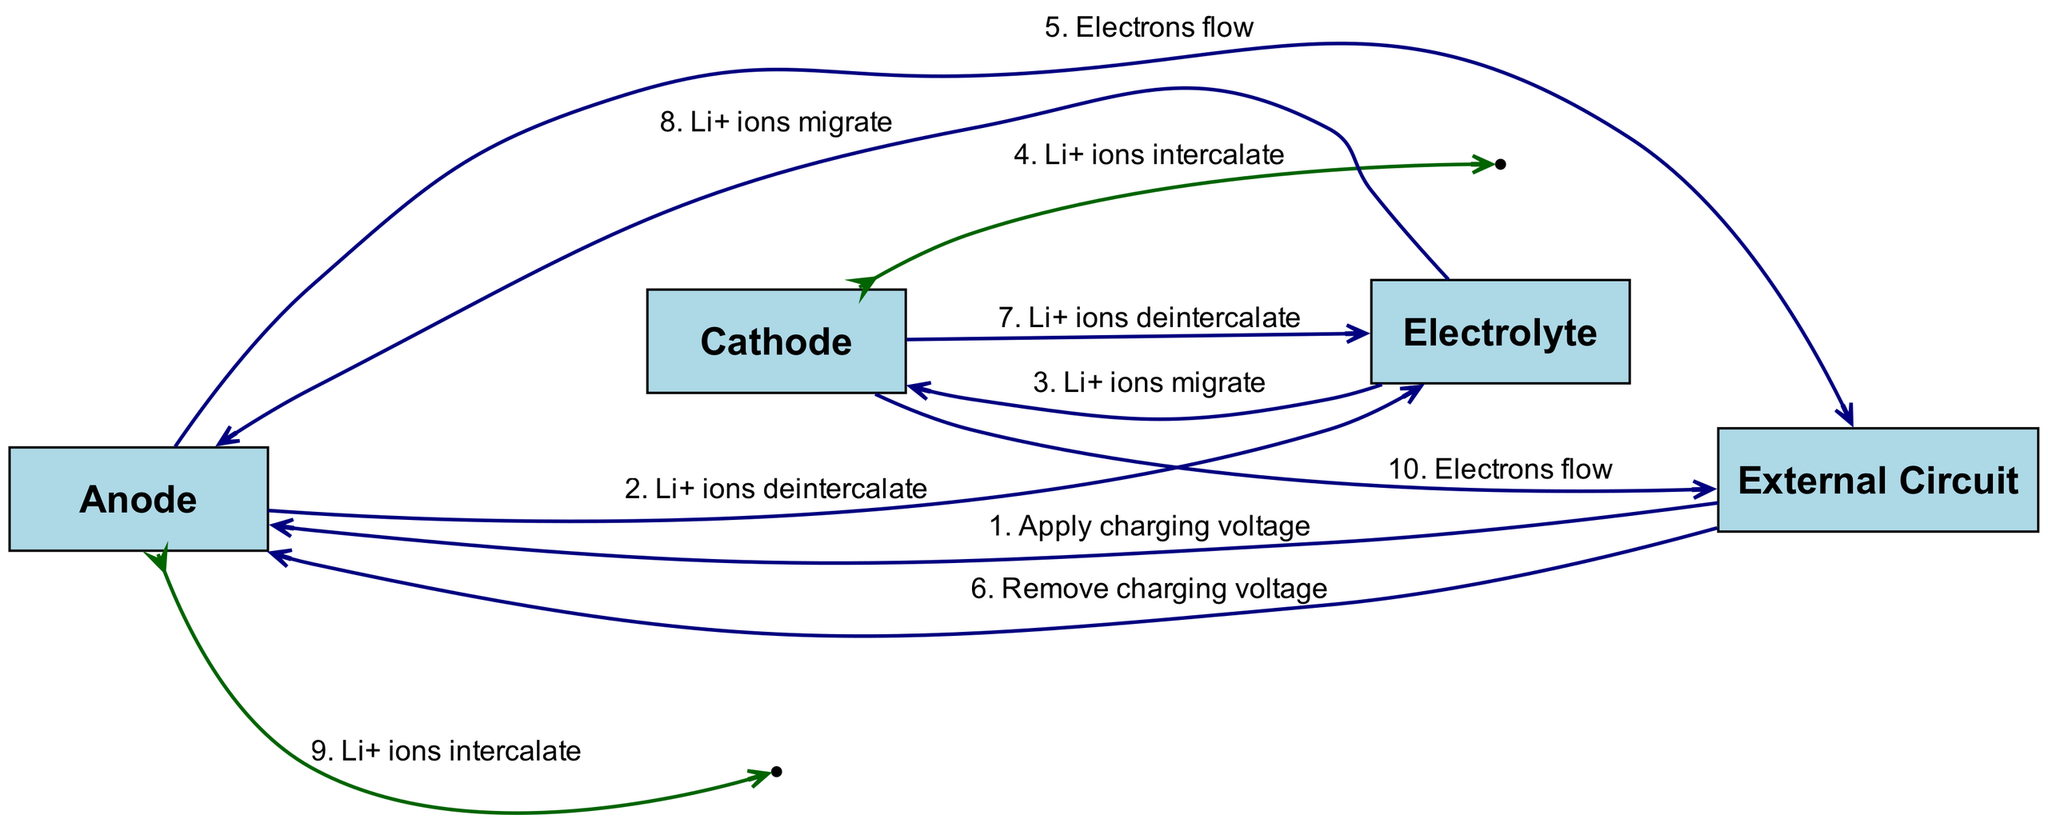What is the first message in the sequence? The first message is labeled as "1. Apply charging voltage," which indicates that the process starts with the application of a charging voltage from the External Circuit to the Anode.
Answer: Apply charging voltage How many participants are there in the diagram? The diagram outlines four participants: Anode, Cathode, Electrolyte, and External Circuit. Hence, the count is determined simply by listing them.
Answer: Four What message follows the deintercalation of Li+ ions at the Anode? After the Li+ ions deintercalate at the Anode, the message that follows is "Li+ ions migrate" from the Electrolyte to the Cathode.
Answer: Li+ ions migrate Which two components exchange electrons? The External Circuit and Cathode exchange electrons, as indicated by the flow of electrons stated in the message for the Cathode.
Answer: External Circuit and Cathode What occurs after electrons flow from the Cathode? After electrons flow from the Cathode, the subsequent message is that the Li+ ions deintercalate from the Cathode. This reveals a direct correlation between electron flow and ion behavior in the battery.
Answer: Li+ ions deintercalate How many messages involve migration of Li+ ions? There are two messages concerning the migration of Li+ ions: one where Li+ ions migrate from the Electrolyte to the Cathode and another where Li+ ions migrate from the Electrolyte back to the Anode. Hence, the total is two.
Answer: Two What is the last action performed by the Anode? The last action performed by the Anode is "Li+ ions intercalate," indicating that during the discharge cycle, it reabsorbs Li+ ions after their migration towards it.
Answer: Li+ ions intercalate Which step involves self-loop for the Anode? The step that involves a self-loop for the Anode is "Li+ ions intercalate," suggesting that it engages in internal actions after receiving Li+ ions from the Electrolyte.
Answer: Li+ ions intercalate 